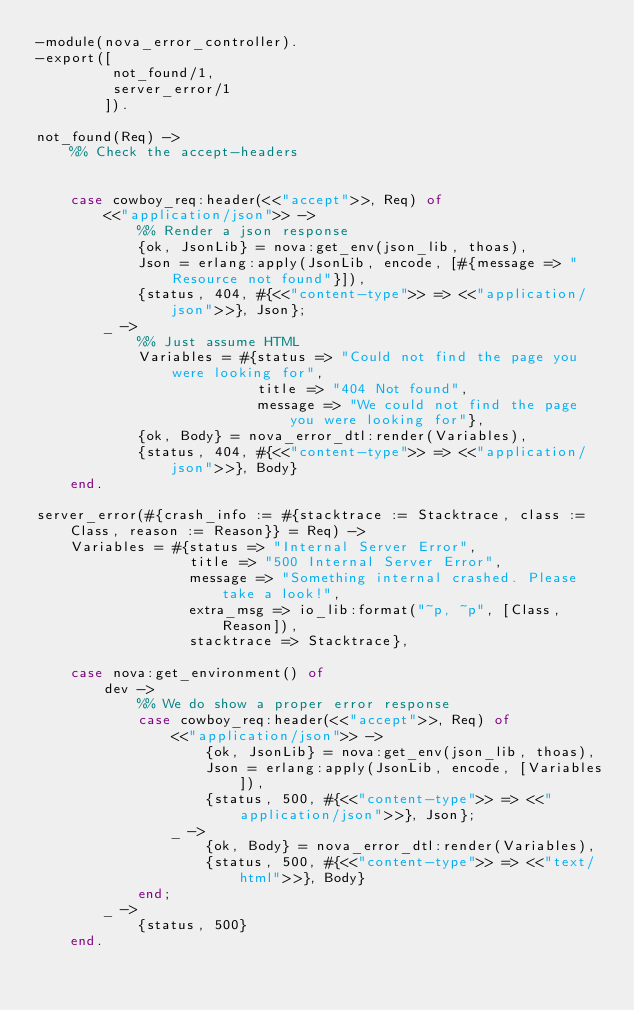<code> <loc_0><loc_0><loc_500><loc_500><_Erlang_>-module(nova_error_controller).
-export([
         not_found/1,
         server_error/1
        ]).

not_found(Req) ->
    %% Check the accept-headers


    case cowboy_req:header(<<"accept">>, Req) of
        <<"application/json">> ->
            %% Render a json response
            {ok, JsonLib} = nova:get_env(json_lib, thoas),
            Json = erlang:apply(JsonLib, encode, [#{message => "Resource not found"}]),
            {status, 404, #{<<"content-type">> => <<"application/json">>}, Json};
        _ ->
            %% Just assume HTML
            Variables = #{status => "Could not find the page you were looking for",
                          title => "404 Not found",
                          message => "We could not find the page you were looking for"},
            {ok, Body} = nova_error_dtl:render(Variables),
            {status, 404, #{<<"content-type">> => <<"application/json">>}, Body}
    end.

server_error(#{crash_info := #{stacktrace := Stacktrace, class := Class, reason := Reason}} = Req) ->
    Variables = #{status => "Internal Server Error",
                  title => "500 Internal Server Error",
                  message => "Something internal crashed. Please take a look!",
                  extra_msg => io_lib:format("~p, ~p", [Class, Reason]),
                  stacktrace => Stacktrace},

    case nova:get_environment() of
        dev ->
            %% We do show a proper error response
            case cowboy_req:header(<<"accept">>, Req) of
                <<"application/json">> ->
                    {ok, JsonLib} = nova:get_env(json_lib, thoas),
                    Json = erlang:apply(JsonLib, encode, [Variables]),
                    {status, 500, #{<<"content-type">> => <<"application/json">>}, Json};
                _ ->
                    {ok, Body} = nova_error_dtl:render(Variables),
                    {status, 500, #{<<"content-type">> => <<"text/html">>}, Body}
            end;
        _ ->
            {status, 500}
    end.
</code> 